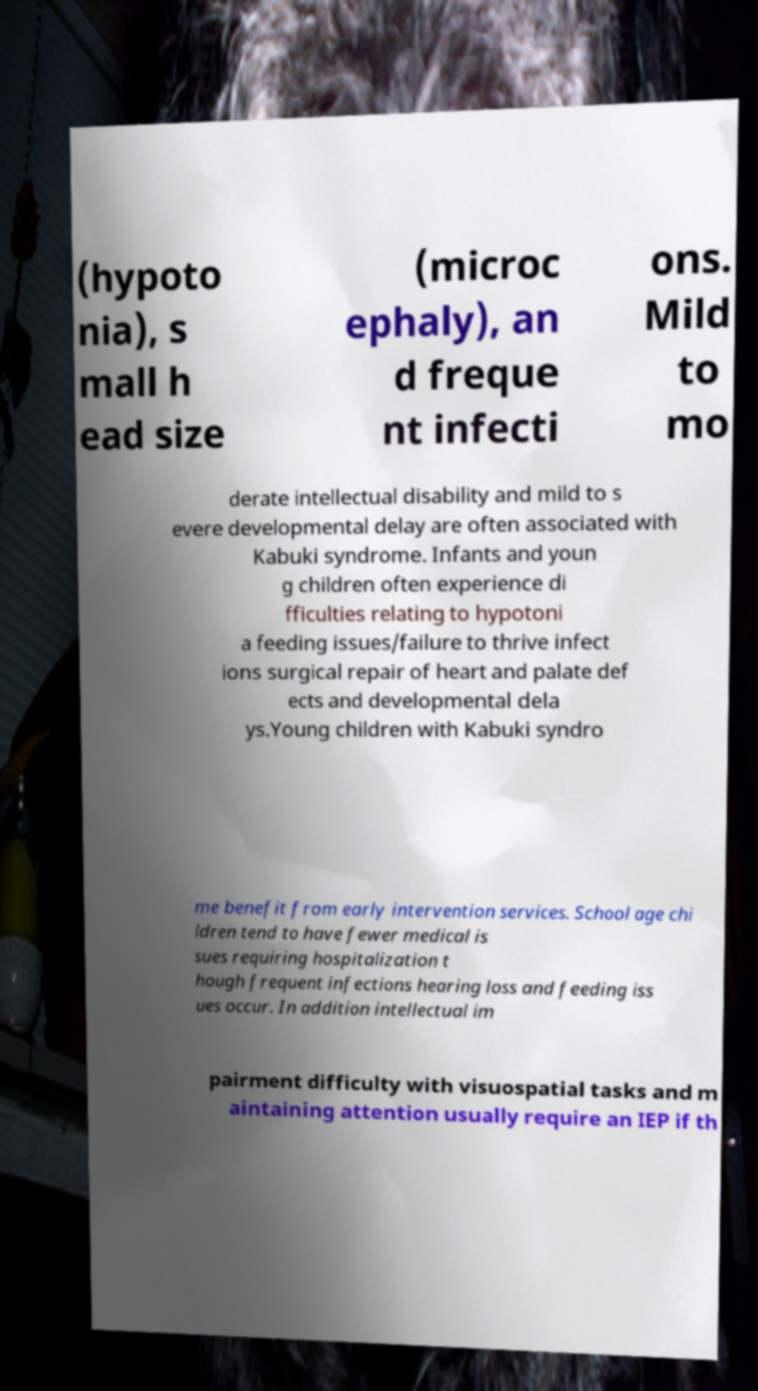Please identify and transcribe the text found in this image. (hypoto nia), s mall h ead size (microc ephaly), an d freque nt infecti ons. Mild to mo derate intellectual disability and mild to s evere developmental delay are often associated with Kabuki syndrome. Infants and youn g children often experience di fficulties relating to hypotoni a feeding issues/failure to thrive infect ions surgical repair of heart and palate def ects and developmental dela ys.Young children with Kabuki syndro me benefit from early intervention services. School age chi ldren tend to have fewer medical is sues requiring hospitalization t hough frequent infections hearing loss and feeding iss ues occur. In addition intellectual im pairment difficulty with visuospatial tasks and m aintaining attention usually require an IEP if th 